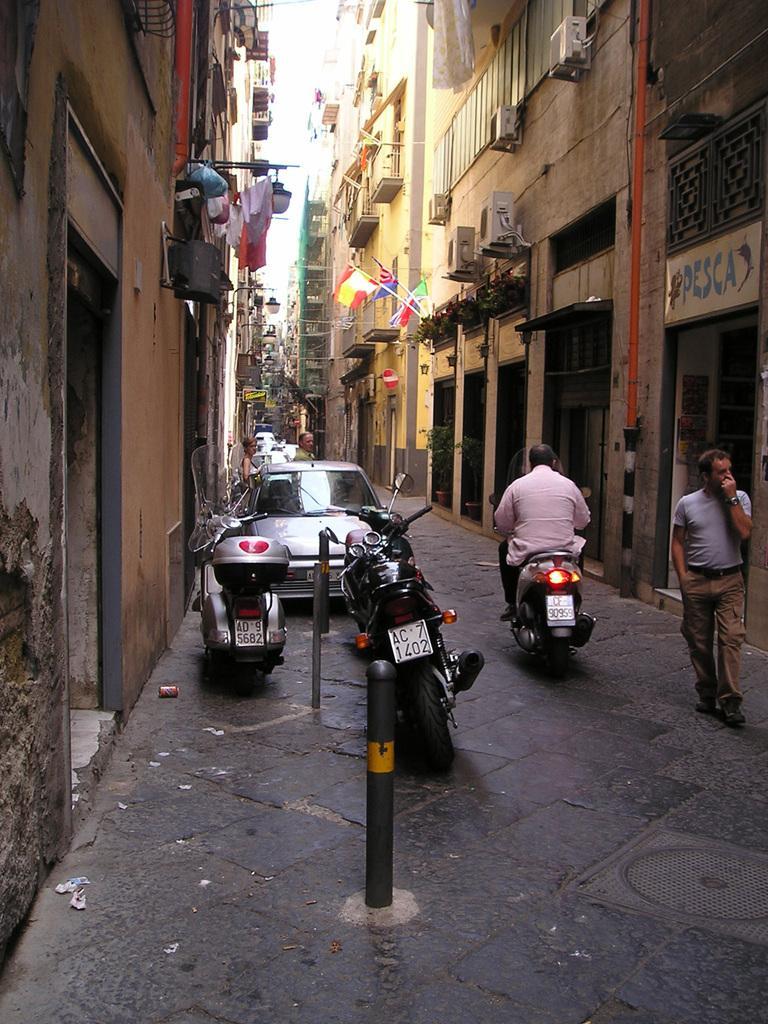Please provide a concise description of this image. In this image in the middle there is a man he is riding bike. On the right there is a man he wears t shirt, trouser and belt, he is walking on the road. On the left there are bikes, cars,buildings and wall. 